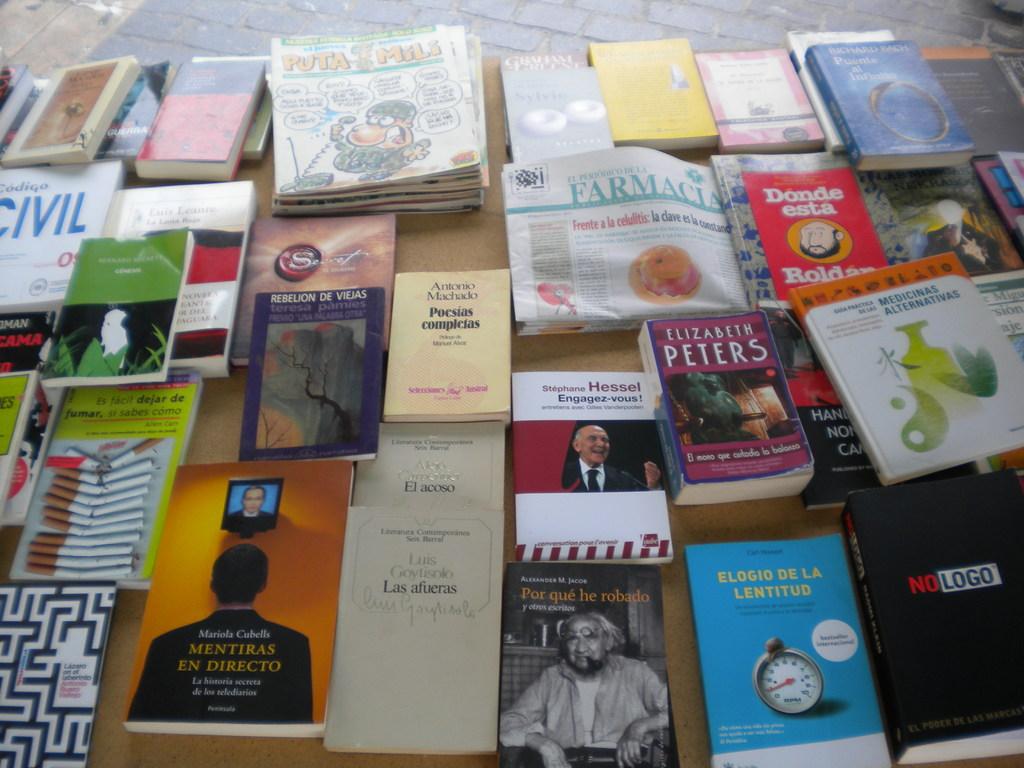What is the bottom right book called?
Make the answer very short. No logo. 